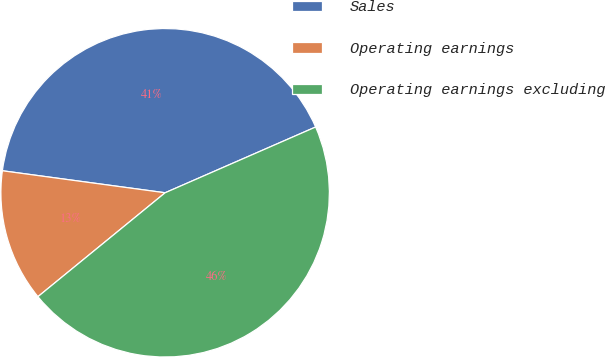<chart> <loc_0><loc_0><loc_500><loc_500><pie_chart><fcel>Sales<fcel>Operating earnings<fcel>Operating earnings excluding<nl><fcel>41.3%<fcel>13.04%<fcel>45.65%<nl></chart> 